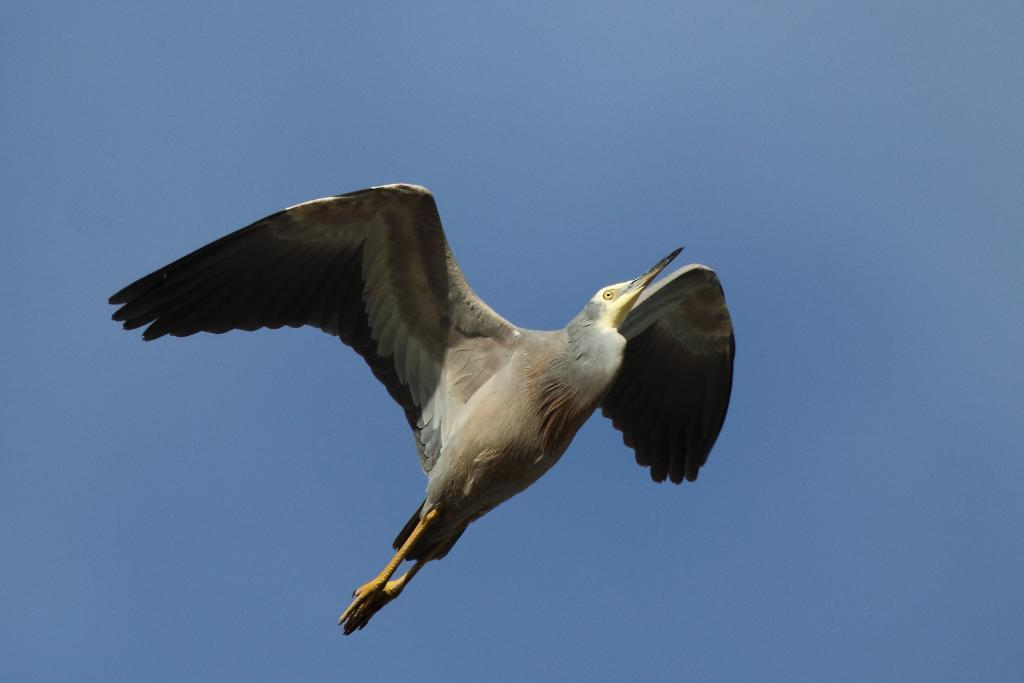What type of animal can be seen in the image? There is a bird in the image. What is the bird doing in the image? The bird is flying in the sky. What type of toy is the bird playing with in the image? There is no toy present in the image, and the bird is not playing with anything. 